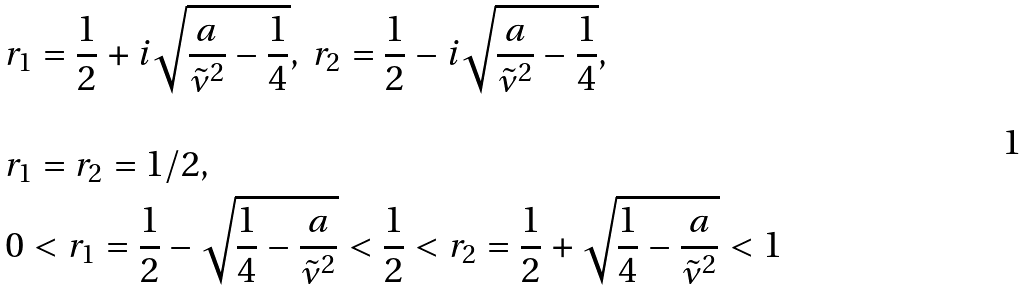<formula> <loc_0><loc_0><loc_500><loc_500>& r _ { 1 } = \frac { 1 } { 2 } + i \sqrt { \frac { a } { \tilde { \nu } ^ { 2 } } - \frac { 1 } { 4 } } , \ r _ { 2 } = \frac { 1 } { 2 } - i \sqrt { \frac { a } { \tilde { \nu } ^ { 2 } } - \frac { 1 } { 4 } } , \\ \\ & r _ { 1 } = r _ { 2 } = 1 / 2 , \\ & 0 < r _ { 1 } = \frac { 1 } { 2 } - \sqrt { \frac { 1 } { 4 } - \frac { a } { \tilde { \nu } ^ { 2 } } } < \frac { 1 } { 2 } < r _ { 2 } = \frac { 1 } { 2 } + \sqrt { \frac { 1 } { 4 } - \frac { a } { \tilde { \nu } ^ { 2 } } } < 1 \</formula> 